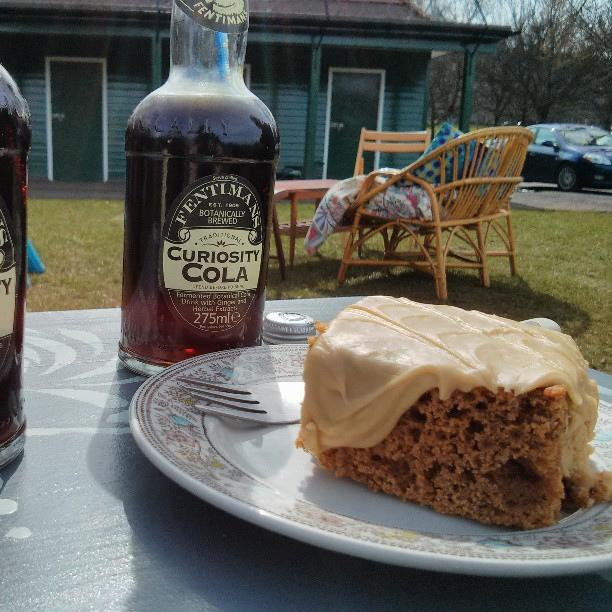What is the fork next to? cake 